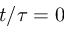<formula> <loc_0><loc_0><loc_500><loc_500>t / \tau = 0</formula> 